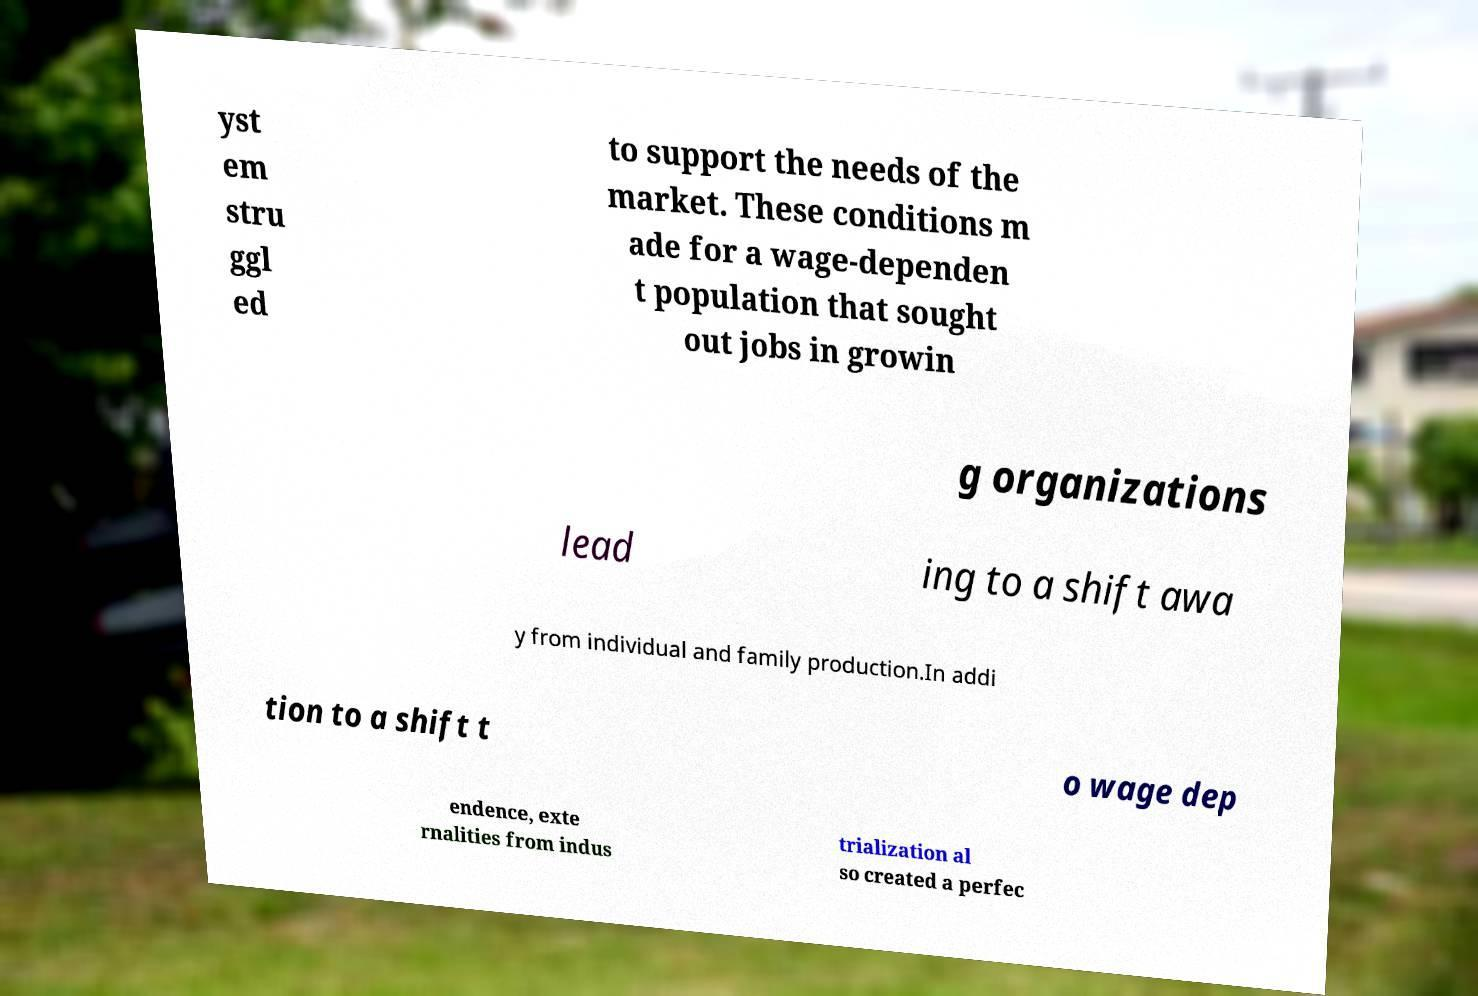What messages or text are displayed in this image? I need them in a readable, typed format. yst em stru ggl ed to support the needs of the market. These conditions m ade for a wage-dependen t population that sought out jobs in growin g organizations lead ing to a shift awa y from individual and family production.In addi tion to a shift t o wage dep endence, exte rnalities from indus trialization al so created a perfec 